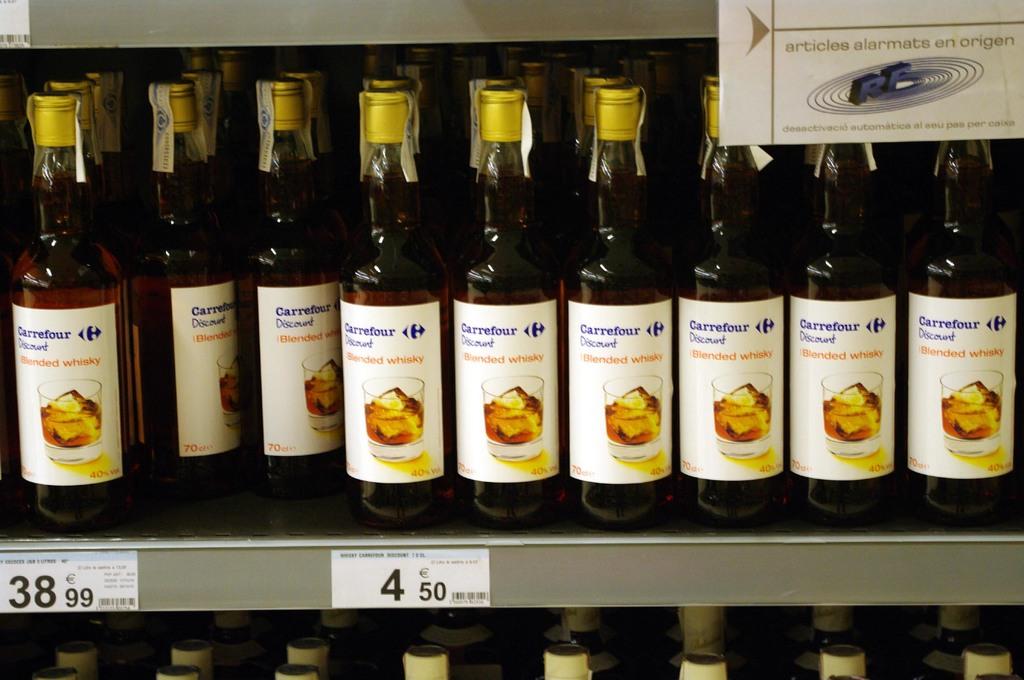What type of liquor is in these bottles?
Provide a short and direct response. Unanswerable. 